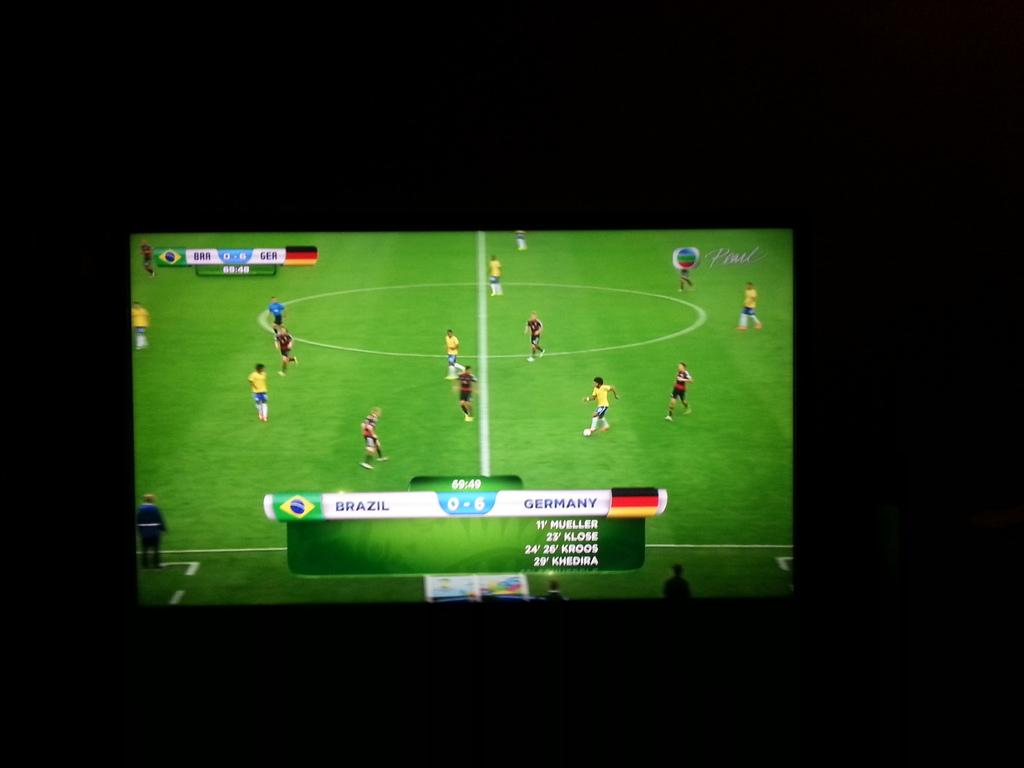<image>
Write a terse but informative summary of the picture. A soccer game being played between Brazil and Germany 